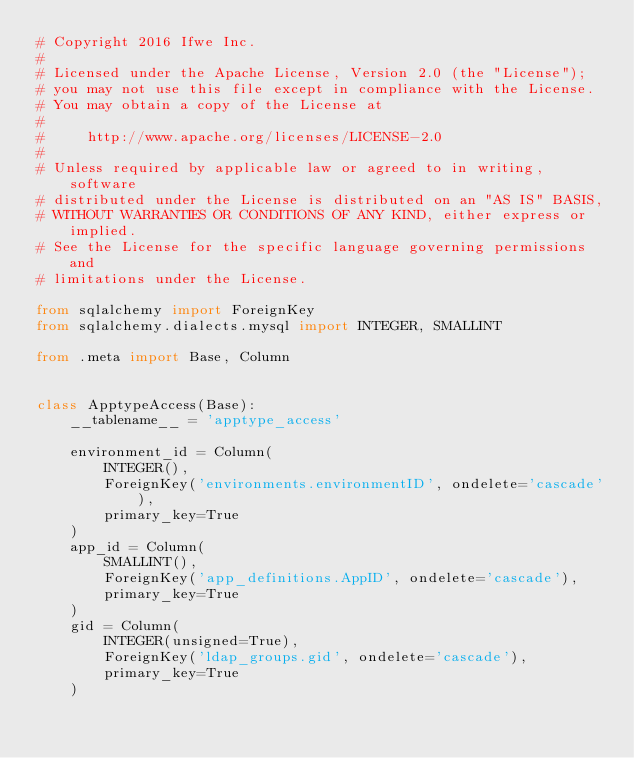Convert code to text. <code><loc_0><loc_0><loc_500><loc_500><_Python_># Copyright 2016 Ifwe Inc.
#
# Licensed under the Apache License, Version 2.0 (the "License");
# you may not use this file except in compliance with the License.
# You may obtain a copy of the License at
#
#     http://www.apache.org/licenses/LICENSE-2.0
#
# Unless required by applicable law or agreed to in writing, software
# distributed under the License is distributed on an "AS IS" BASIS,
# WITHOUT WARRANTIES OR CONDITIONS OF ANY KIND, either express or implied.
# See the License for the specific language governing permissions and
# limitations under the License.

from sqlalchemy import ForeignKey
from sqlalchemy.dialects.mysql import INTEGER, SMALLINT

from .meta import Base, Column


class ApptypeAccess(Base):
    __tablename__ = 'apptype_access'
    
    environment_id = Column(
        INTEGER(),
        ForeignKey('environments.environmentID', ondelete='cascade'),
        primary_key=True
    )
    app_id = Column(
        SMALLINT(),
        ForeignKey('app_definitions.AppID', ondelete='cascade'),
        primary_key=True
    )
    gid = Column(
        INTEGER(unsigned=True),
        ForeignKey('ldap_groups.gid', ondelete='cascade'),
        primary_key=True
    )
</code> 